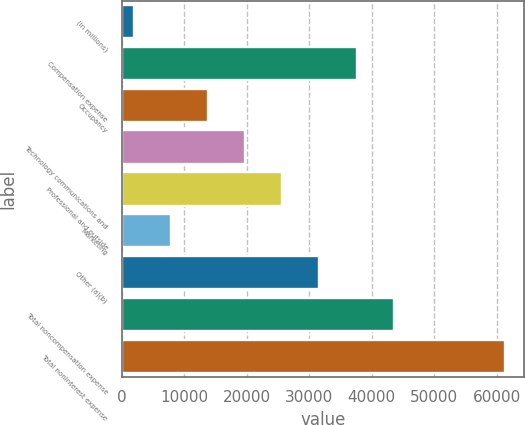<chart> <loc_0><loc_0><loc_500><loc_500><bar_chart><fcel>(in millions)<fcel>Compensation expense<fcel>Occupancy<fcel>Technology communications and<fcel>Professional and outside<fcel>Marketing<fcel>Other (a)(b)<fcel>Total noncompensation expense<fcel>Total noninterest expense<nl><fcel>2014<fcel>37570<fcel>13866<fcel>19792<fcel>25718<fcel>7940<fcel>31644<fcel>43496<fcel>61274<nl></chart> 